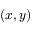<formula> <loc_0><loc_0><loc_500><loc_500>( x , y )</formula> 